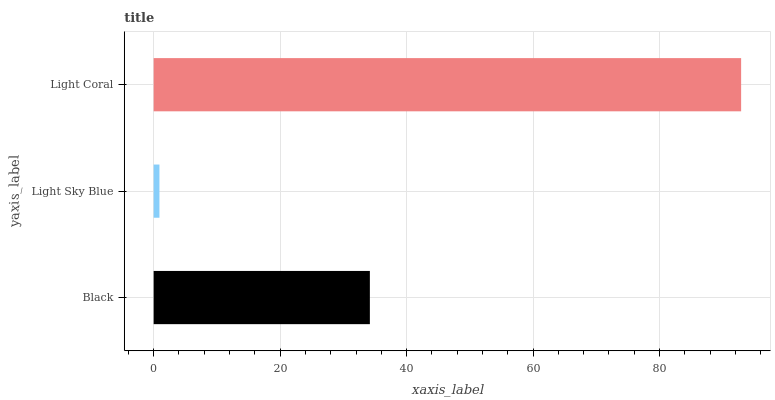Is Light Sky Blue the minimum?
Answer yes or no. Yes. Is Light Coral the maximum?
Answer yes or no. Yes. Is Light Coral the minimum?
Answer yes or no. No. Is Light Sky Blue the maximum?
Answer yes or no. No. Is Light Coral greater than Light Sky Blue?
Answer yes or no. Yes. Is Light Sky Blue less than Light Coral?
Answer yes or no. Yes. Is Light Sky Blue greater than Light Coral?
Answer yes or no. No. Is Light Coral less than Light Sky Blue?
Answer yes or no. No. Is Black the high median?
Answer yes or no. Yes. Is Black the low median?
Answer yes or no. Yes. Is Light Sky Blue the high median?
Answer yes or no. No. Is Light Sky Blue the low median?
Answer yes or no. No. 